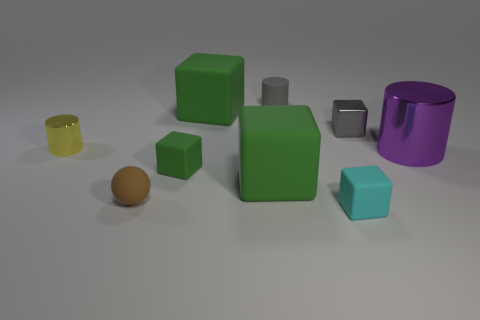Do the tiny matte ball and the matte cylinder have the same color?
Your answer should be compact. No. How big is the block that is both right of the tiny gray matte object and in front of the small yellow metallic object?
Provide a succinct answer. Small. What is the color of the cylinder that is in front of the tiny gray metal object and to the right of the tiny yellow cylinder?
Ensure brevity in your answer.  Purple. There is a gray object that is the same material as the purple thing; what size is it?
Your answer should be compact. Small. Does the cylinder that is behind the small metallic block have the same color as the small cube that is behind the large purple metal thing?
Offer a terse response. Yes. There is a thing left of the brown thing; is its size the same as the tiny gray cylinder?
Offer a very short reply. Yes. How many things are things that are right of the yellow thing or green rubber things that are in front of the tiny gray block?
Offer a terse response. 8. There is a tiny cube on the left side of the tiny cyan thing; is it the same color as the small matte ball?
Your answer should be very brief. No. What number of shiny things are either large yellow spheres or large cylinders?
Give a very brief answer. 1. What is the shape of the tiny brown rubber thing?
Ensure brevity in your answer.  Sphere. 